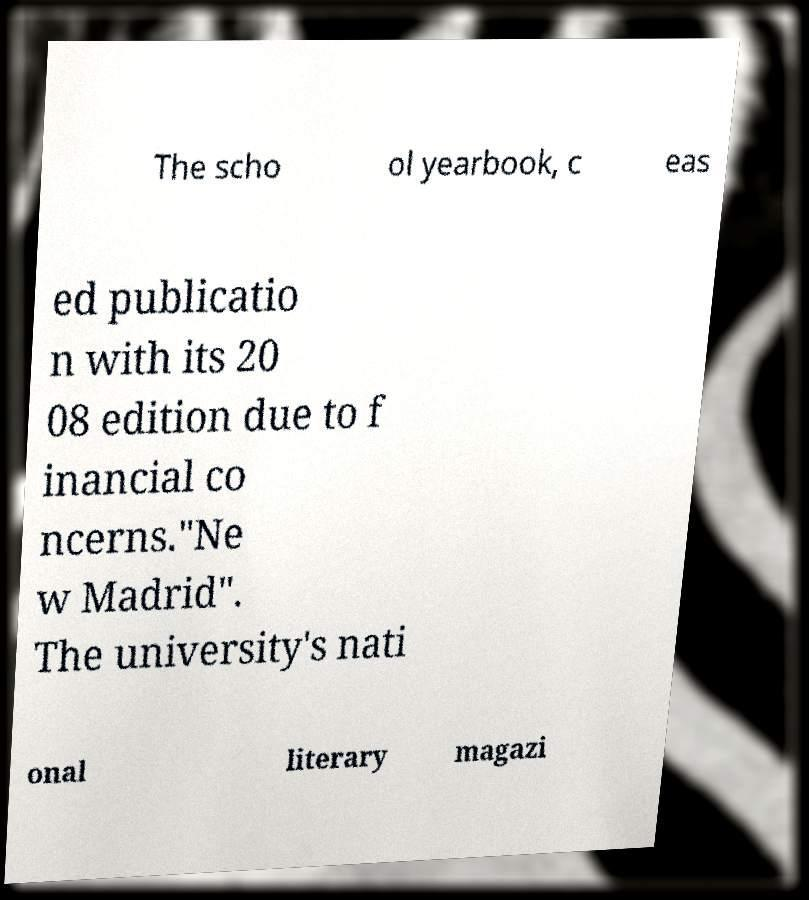Please identify and transcribe the text found in this image. The scho ol yearbook, c eas ed publicatio n with its 20 08 edition due to f inancial co ncerns."Ne w Madrid". The university's nati onal literary magazi 